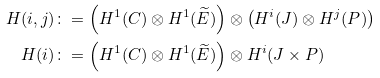<formula> <loc_0><loc_0><loc_500><loc_500>H ( i , j ) \colon & = \left ( H ^ { 1 } ( C ) \otimes H ^ { 1 } ( \widetilde { E } ) \right ) \otimes \left ( H ^ { i } ( J ) \otimes H ^ { j } ( P ) \right ) \\ H ( i ) \colon & = \left ( H ^ { 1 } ( C ) \otimes H ^ { 1 } ( \widetilde { E } ) \right ) \otimes H ^ { i } ( J \times P )</formula> 